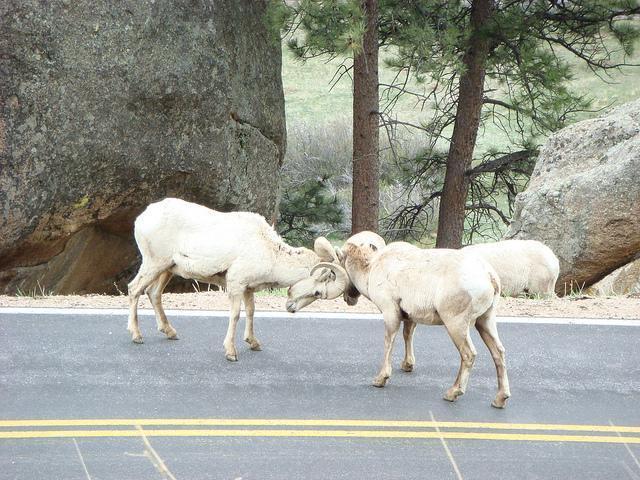How many animals are in this photo?
Give a very brief answer. 3. How many sheep are there?
Give a very brief answer. 3. How many round donuts have nuts on them in the image?
Give a very brief answer. 0. 